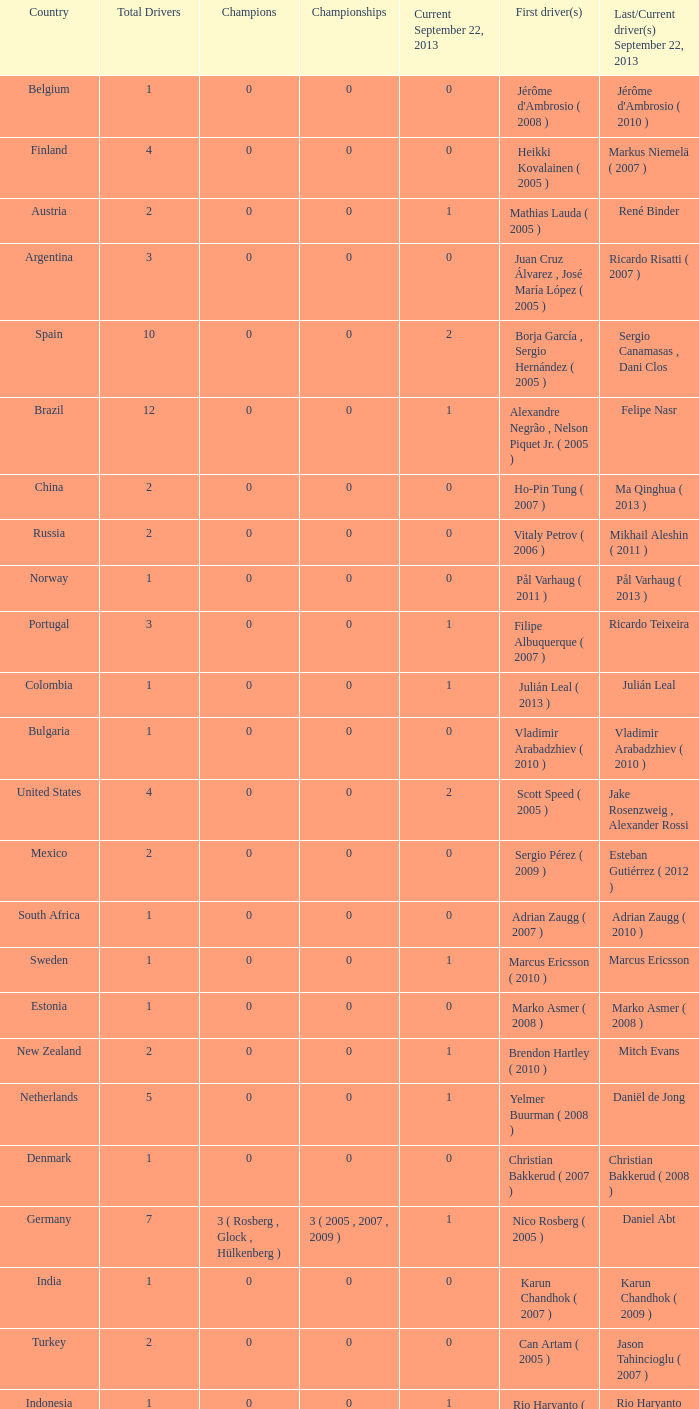How many champions were there when the last driver for September 22, 2013 was vladimir arabadzhiev ( 2010 )? 0.0. 